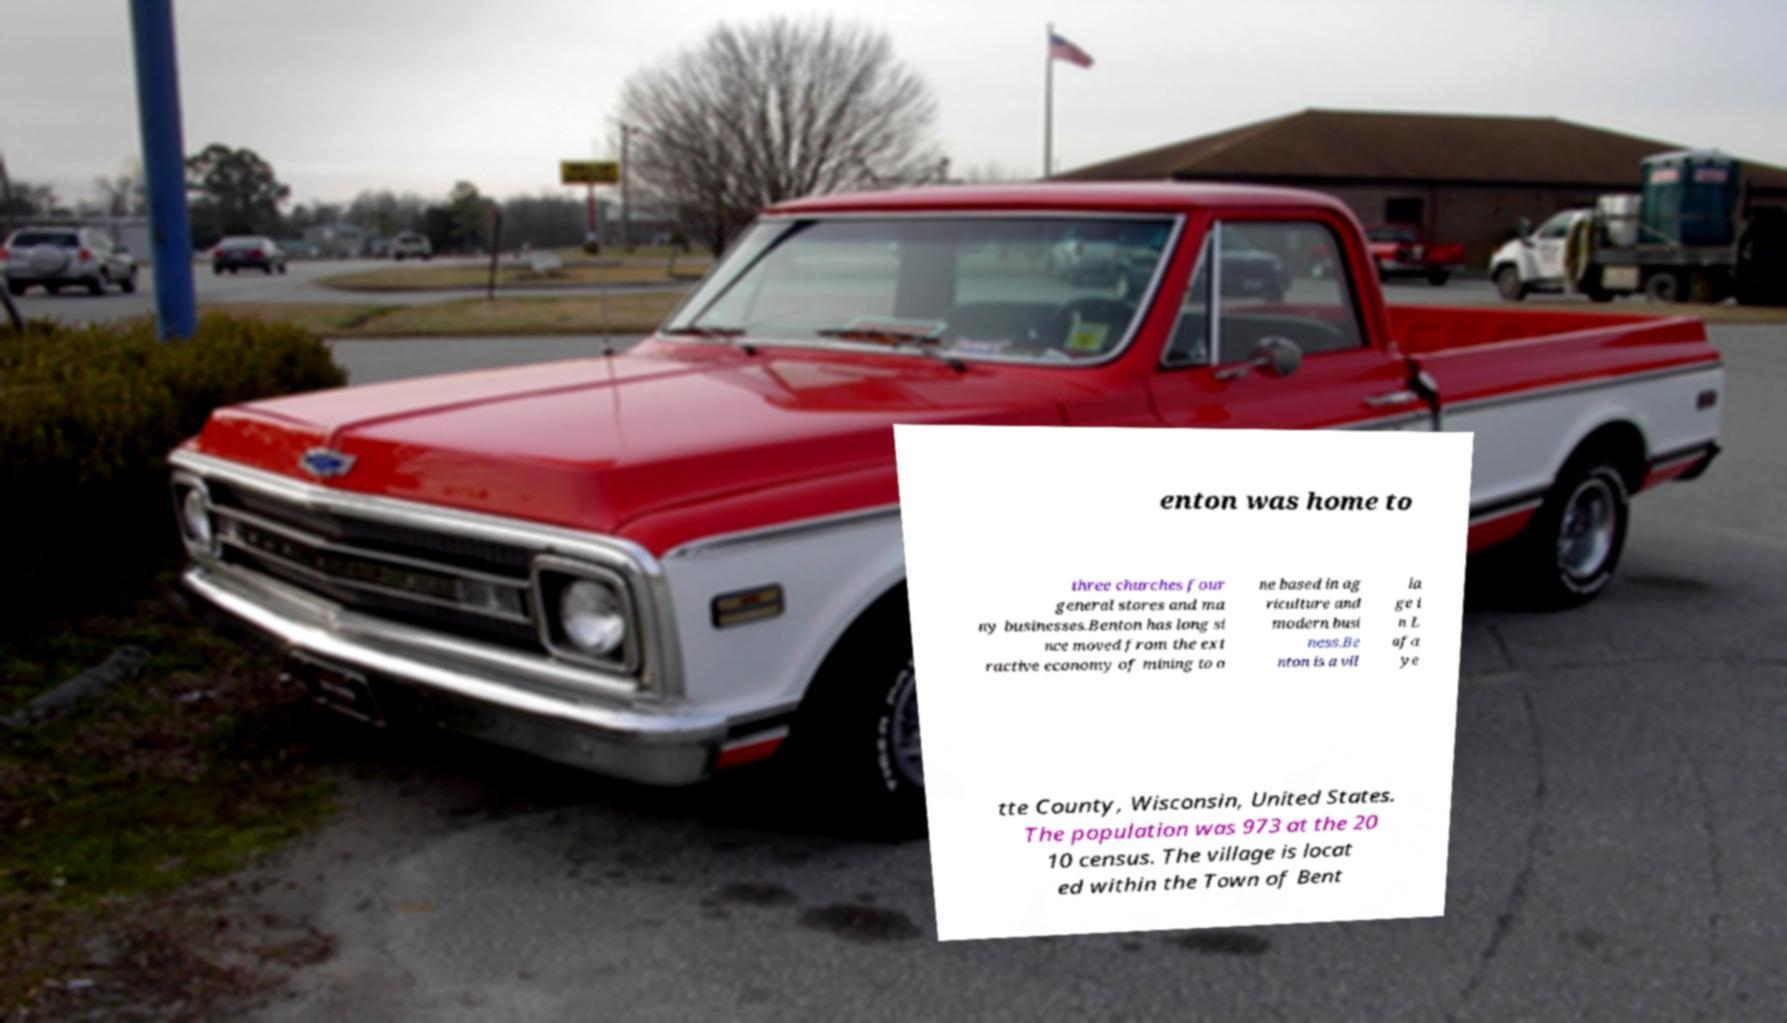Please identify and transcribe the text found in this image. enton was home to three churches four general stores and ma ny businesses.Benton has long si nce moved from the ext ractive economy of mining to o ne based in ag riculture and modern busi ness.Be nton is a vil la ge i n L afa ye tte County, Wisconsin, United States. The population was 973 at the 20 10 census. The village is locat ed within the Town of Bent 